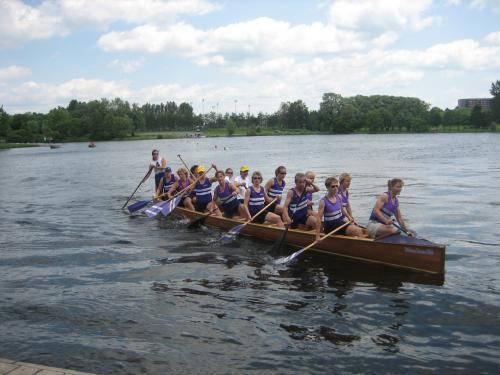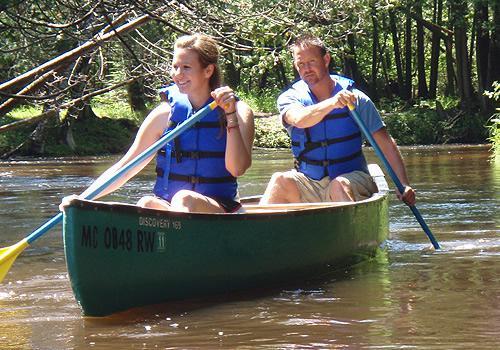The first image is the image on the left, the second image is the image on the right. Analyze the images presented: Is the assertion "In one image, exactly two people, a man and a woman, are rowing a green canoe." valid? Answer yes or no. Yes. The first image is the image on the left, the second image is the image on the right. Evaluate the accuracy of this statement regarding the images: "An image shows one dark green canoe with two riders.". Is it true? Answer yes or no. Yes. 